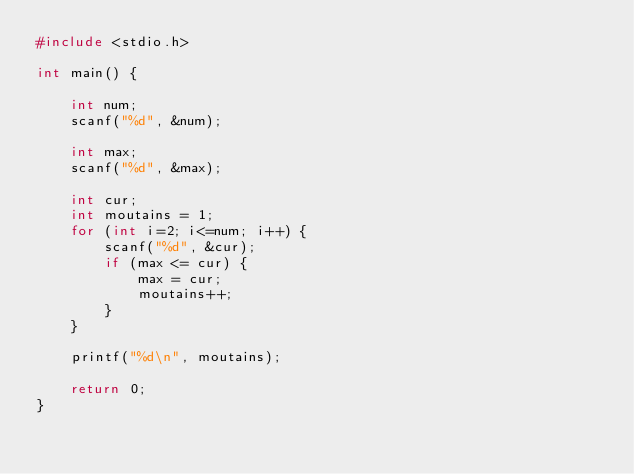<code> <loc_0><loc_0><loc_500><loc_500><_C_>#include <stdio.h>

int main() {

    int num;
    scanf("%d", &num);

    int max;
    scanf("%d", &max);

    int cur;
    int moutains = 1;
    for (int i=2; i<=num; i++) {
        scanf("%d", &cur);
        if (max <= cur) {
            max = cur;
            moutains++;
        }
    }

    printf("%d\n", moutains);

    return 0;
}
</code> 